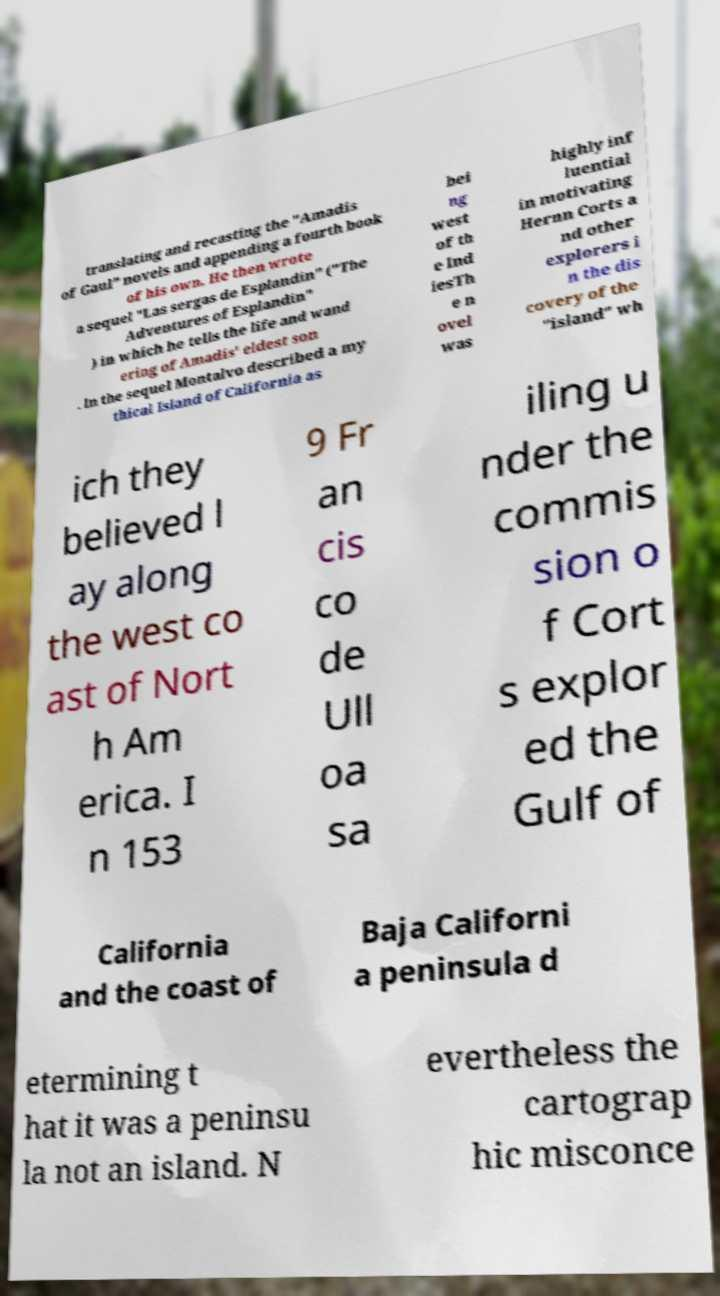Can you accurately transcribe the text from the provided image for me? translating and recasting the "Amadis of Gaul" novels and appending a fourth book of his own. He then wrote a sequel "Las sergas de Esplandin" ("The Adventures of Esplandin" ) in which he tells the life and wand ering of Amadis' eldest son . In the sequel Montalvo described a my thical Island of California as bei ng west of th e Ind iesTh e n ovel was highly inf luential in motivating Hernn Corts a nd other explorers i n the dis covery of the "island" wh ich they believed l ay along the west co ast of Nort h Am erica. I n 153 9 Fr an cis co de Ull oa sa iling u nder the commis sion o f Cort s explor ed the Gulf of California and the coast of Baja Californi a peninsula d etermining t hat it was a peninsu la not an island. N evertheless the cartograp hic misconce 